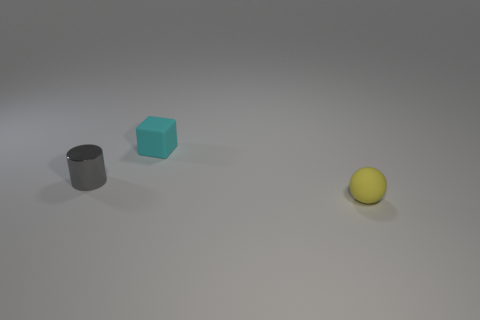Add 1 small blue spheres. How many objects exist? 4 Subtract all cubes. How many objects are left? 2 Subtract all big red matte objects. Subtract all tiny metallic cylinders. How many objects are left? 2 Add 2 small matte blocks. How many small matte blocks are left? 3 Add 2 gray metal cylinders. How many gray metal cylinders exist? 3 Subtract 1 gray cylinders. How many objects are left? 2 